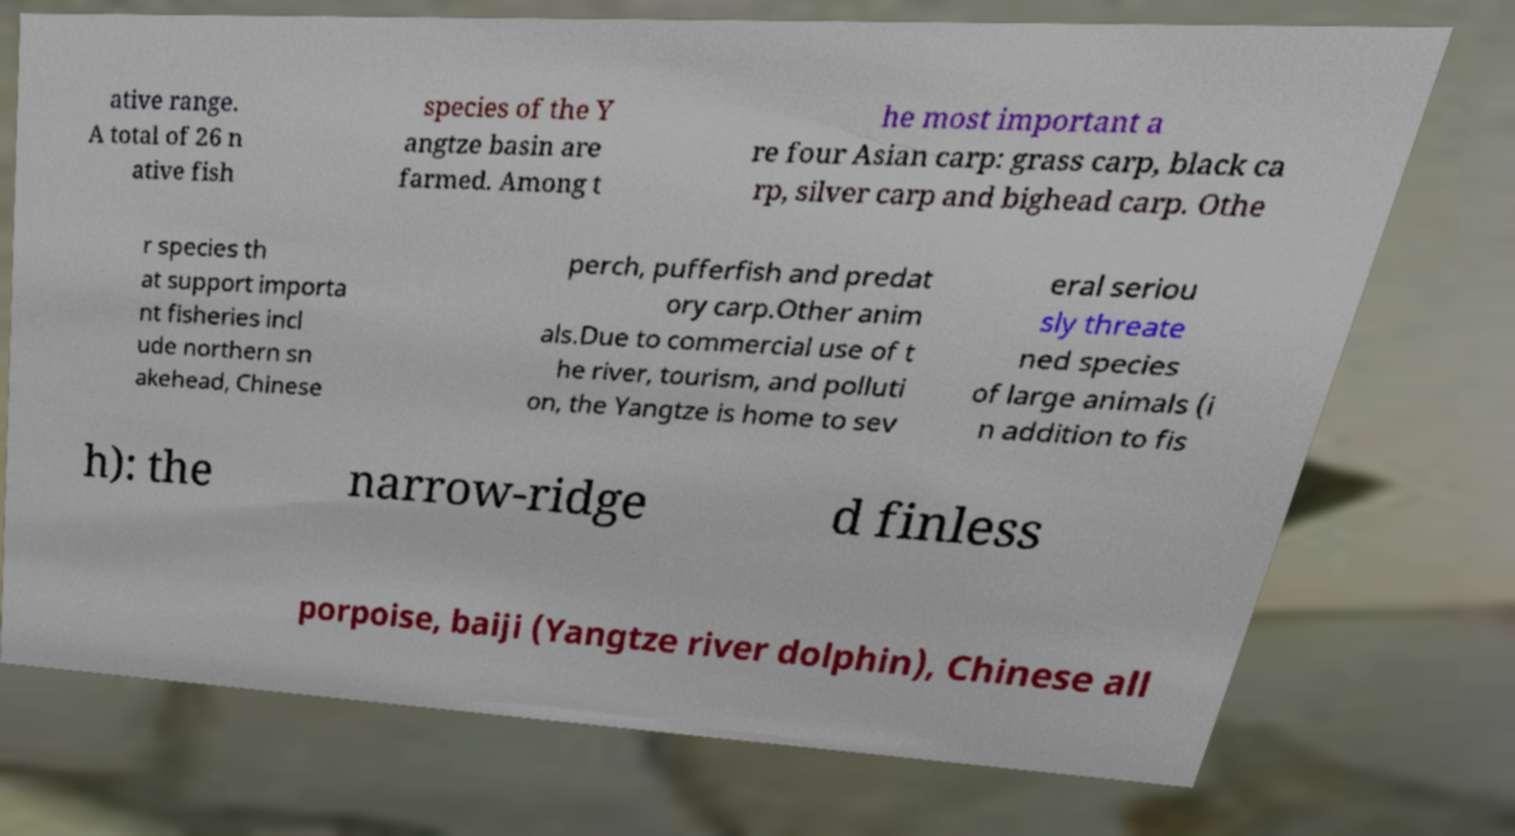What messages or text are displayed in this image? I need them in a readable, typed format. ative range. A total of 26 n ative fish species of the Y angtze basin are farmed. Among t he most important a re four Asian carp: grass carp, black ca rp, silver carp and bighead carp. Othe r species th at support importa nt fisheries incl ude northern sn akehead, Chinese perch, pufferfish and predat ory carp.Other anim als.Due to commercial use of t he river, tourism, and polluti on, the Yangtze is home to sev eral seriou sly threate ned species of large animals (i n addition to fis h): the narrow-ridge d finless porpoise, baiji (Yangtze river dolphin), Chinese all 